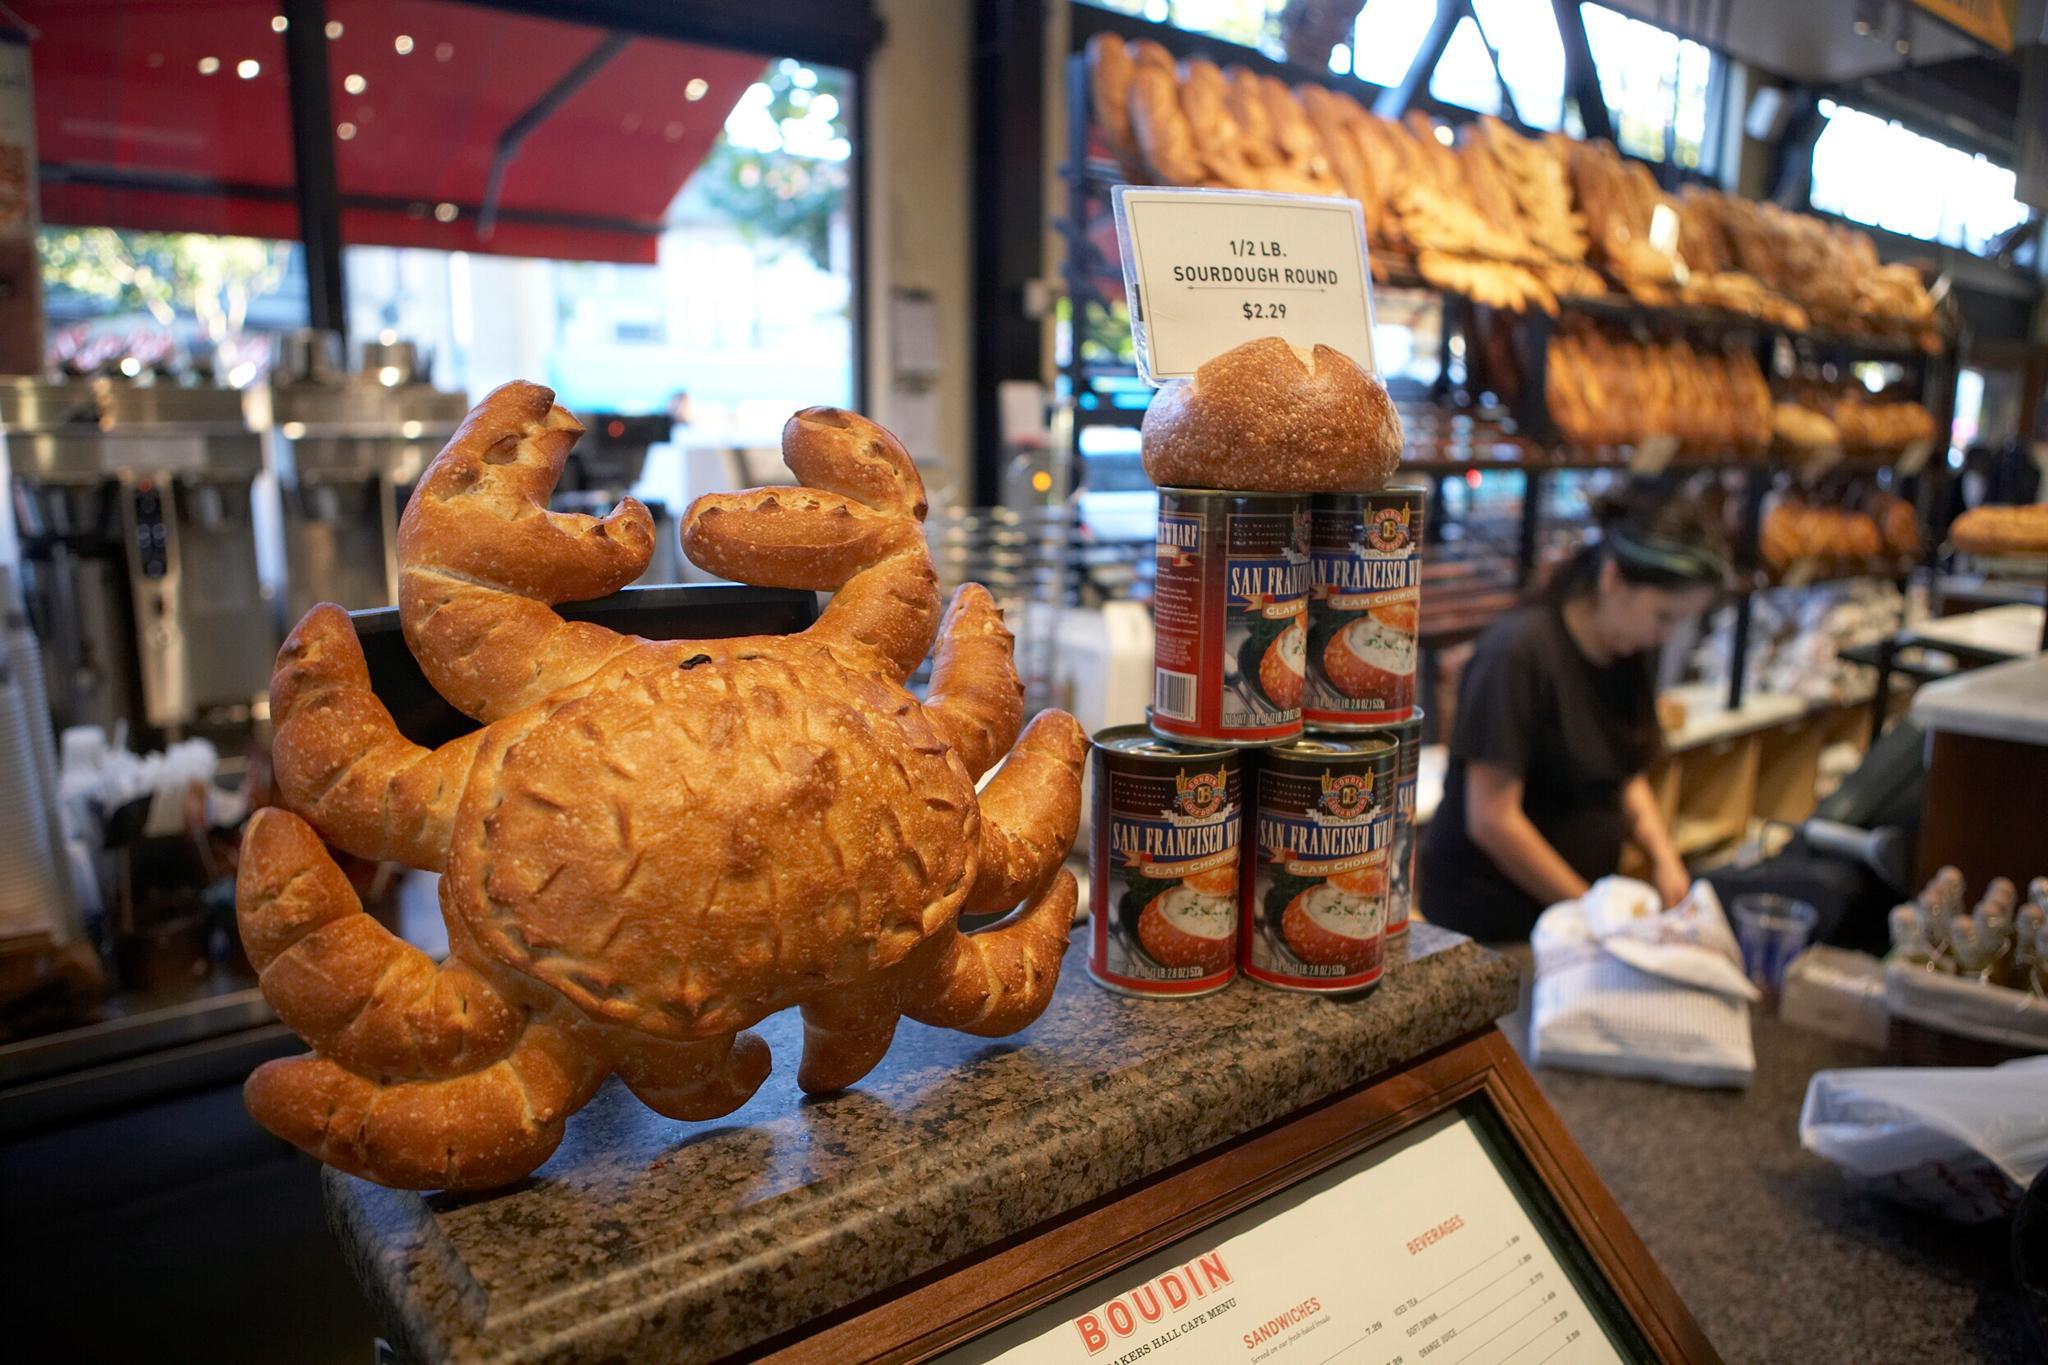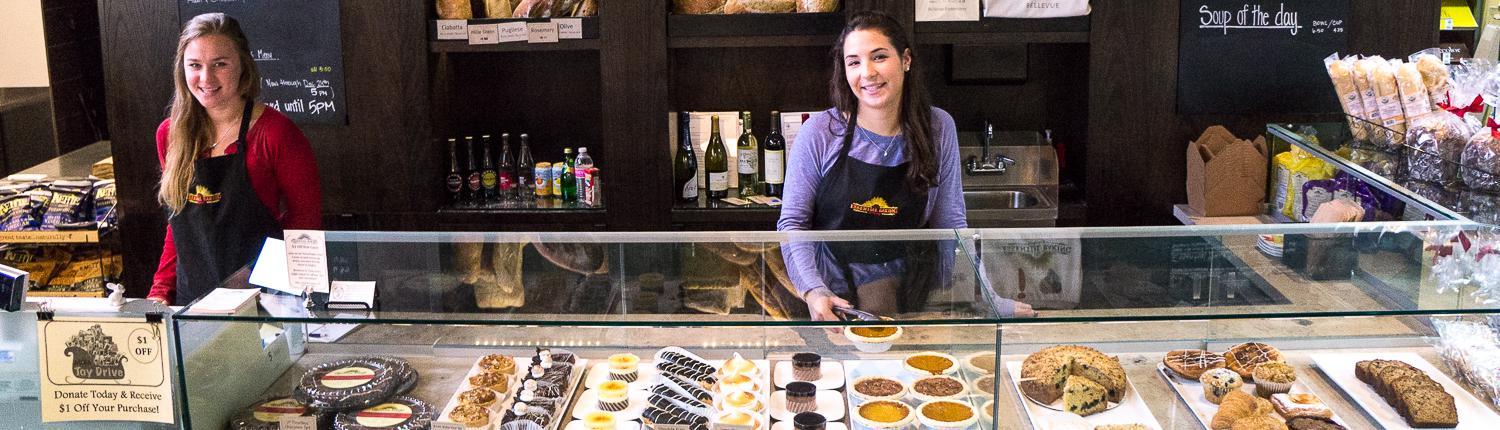The first image is the image on the left, the second image is the image on the right. Analyze the images presented: Is the assertion "There are more women than there are men." valid? Answer yes or no. Yes. The first image is the image on the left, the second image is the image on the right. Evaluate the accuracy of this statement regarding the images: "Has atleast one picture of a lone bearded man". Is it true? Answer yes or no. No. 